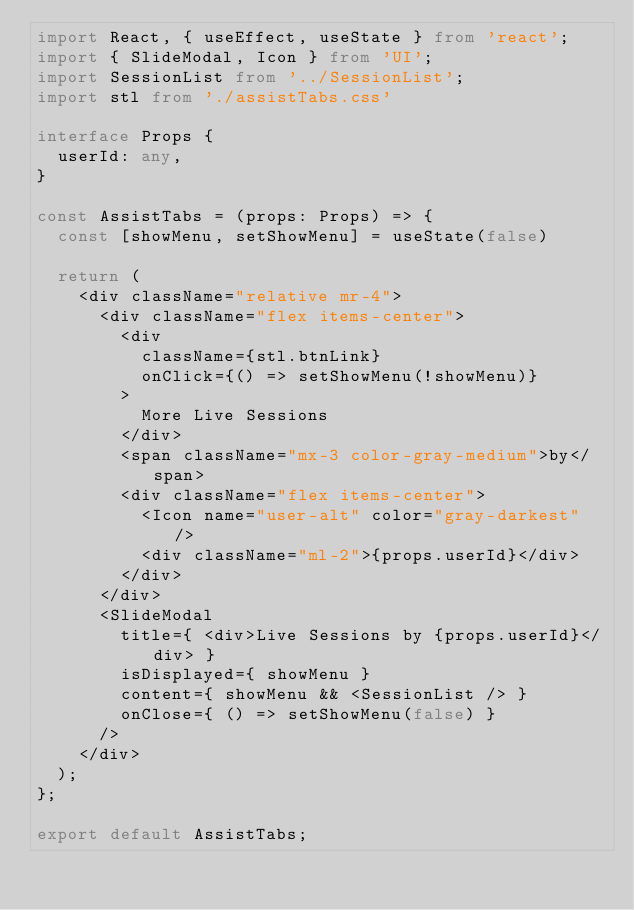<code> <loc_0><loc_0><loc_500><loc_500><_TypeScript_>import React, { useEffect, useState } from 'react';
import { SlideModal, Icon } from 'UI';
import SessionList from '../SessionList';
import stl from './assistTabs.css'

interface Props {
  userId: any,
}

const AssistTabs = (props: Props) => {
  const [showMenu, setShowMenu] = useState(false)

  return (
    <div className="relative mr-4">
      <div className="flex items-center">
        <div
          className={stl.btnLink}
          onClick={() => setShowMenu(!showMenu)}
        >
          More Live Sessions
        </div>
        <span className="mx-3 color-gray-medium">by</span>
        <div className="flex items-center">
          <Icon name="user-alt" color="gray-darkest" />
          <div className="ml-2">{props.userId}</div>
        </div>
      </div>
      <SlideModal
        title={ <div>Live Sessions by {props.userId}</div> }
        isDisplayed={ showMenu }
        content={ showMenu && <SessionList /> }
        onClose={ () => setShowMenu(false) }
      />
    </div>
  );
};

export default AssistTabs;</code> 